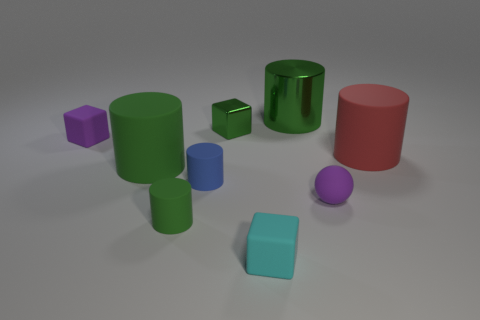Subtract all green cylinders. How many were subtracted if there are1green cylinders left? 2 Subtract all red blocks. How many green cylinders are left? 3 Subtract all red cylinders. How many cylinders are left? 4 Subtract all big red cylinders. How many cylinders are left? 4 Add 1 tiny matte spheres. How many objects exist? 10 Subtract all cyan cylinders. Subtract all yellow balls. How many cylinders are left? 5 Subtract all cubes. How many objects are left? 6 Subtract all tiny cyan things. Subtract all tiny purple things. How many objects are left? 6 Add 2 purple rubber objects. How many purple rubber objects are left? 4 Add 1 big green matte spheres. How many big green matte spheres exist? 1 